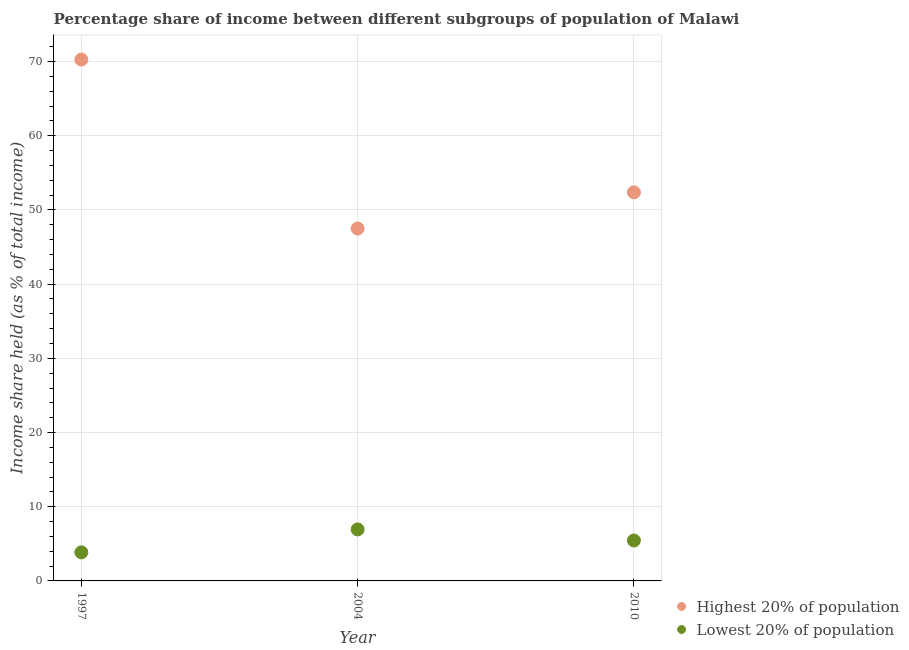How many different coloured dotlines are there?
Provide a succinct answer. 2. What is the income share held by lowest 20% of the population in 1997?
Offer a very short reply. 3.85. Across all years, what is the maximum income share held by highest 20% of the population?
Offer a terse response. 70.27. Across all years, what is the minimum income share held by lowest 20% of the population?
Your answer should be very brief. 3.85. In which year was the income share held by lowest 20% of the population minimum?
Your answer should be compact. 1997. What is the total income share held by highest 20% of the population in the graph?
Provide a short and direct response. 170.13. What is the difference between the income share held by lowest 20% of the population in 1997 and that in 2004?
Give a very brief answer. -3.09. What is the difference between the income share held by highest 20% of the population in 2010 and the income share held by lowest 20% of the population in 2004?
Your answer should be compact. 45.43. What is the average income share held by highest 20% of the population per year?
Provide a short and direct response. 56.71. In the year 1997, what is the difference between the income share held by highest 20% of the population and income share held by lowest 20% of the population?
Offer a very short reply. 66.42. What is the ratio of the income share held by highest 20% of the population in 1997 to that in 2010?
Provide a succinct answer. 1.34. Is the income share held by lowest 20% of the population in 1997 less than that in 2004?
Ensure brevity in your answer.  Yes. What is the difference between the highest and the second highest income share held by lowest 20% of the population?
Offer a very short reply. 1.49. What is the difference between the highest and the lowest income share held by lowest 20% of the population?
Your answer should be very brief. 3.09. In how many years, is the income share held by lowest 20% of the population greater than the average income share held by lowest 20% of the population taken over all years?
Keep it short and to the point. 2. Is the income share held by highest 20% of the population strictly greater than the income share held by lowest 20% of the population over the years?
Keep it short and to the point. Yes. Is the income share held by lowest 20% of the population strictly less than the income share held by highest 20% of the population over the years?
Your response must be concise. Yes. How many dotlines are there?
Your answer should be very brief. 2. How many years are there in the graph?
Make the answer very short. 3. What is the difference between two consecutive major ticks on the Y-axis?
Make the answer very short. 10. How are the legend labels stacked?
Provide a short and direct response. Vertical. What is the title of the graph?
Provide a succinct answer. Percentage share of income between different subgroups of population of Malawi. Does "Foreign Liabilities" appear as one of the legend labels in the graph?
Your answer should be very brief. No. What is the label or title of the X-axis?
Your answer should be compact. Year. What is the label or title of the Y-axis?
Give a very brief answer. Income share held (as % of total income). What is the Income share held (as % of total income) of Highest 20% of population in 1997?
Provide a short and direct response. 70.27. What is the Income share held (as % of total income) in Lowest 20% of population in 1997?
Keep it short and to the point. 3.85. What is the Income share held (as % of total income) in Highest 20% of population in 2004?
Provide a succinct answer. 47.49. What is the Income share held (as % of total income) in Lowest 20% of population in 2004?
Your answer should be compact. 6.94. What is the Income share held (as % of total income) of Highest 20% of population in 2010?
Offer a terse response. 52.37. What is the Income share held (as % of total income) of Lowest 20% of population in 2010?
Provide a short and direct response. 5.45. Across all years, what is the maximum Income share held (as % of total income) of Highest 20% of population?
Ensure brevity in your answer.  70.27. Across all years, what is the maximum Income share held (as % of total income) of Lowest 20% of population?
Your answer should be compact. 6.94. Across all years, what is the minimum Income share held (as % of total income) in Highest 20% of population?
Offer a terse response. 47.49. Across all years, what is the minimum Income share held (as % of total income) of Lowest 20% of population?
Your answer should be very brief. 3.85. What is the total Income share held (as % of total income) in Highest 20% of population in the graph?
Give a very brief answer. 170.13. What is the total Income share held (as % of total income) in Lowest 20% of population in the graph?
Provide a succinct answer. 16.24. What is the difference between the Income share held (as % of total income) in Highest 20% of population in 1997 and that in 2004?
Make the answer very short. 22.78. What is the difference between the Income share held (as % of total income) in Lowest 20% of population in 1997 and that in 2004?
Your answer should be very brief. -3.09. What is the difference between the Income share held (as % of total income) in Highest 20% of population in 2004 and that in 2010?
Keep it short and to the point. -4.88. What is the difference between the Income share held (as % of total income) of Lowest 20% of population in 2004 and that in 2010?
Provide a succinct answer. 1.49. What is the difference between the Income share held (as % of total income) in Highest 20% of population in 1997 and the Income share held (as % of total income) in Lowest 20% of population in 2004?
Your answer should be compact. 63.33. What is the difference between the Income share held (as % of total income) in Highest 20% of population in 1997 and the Income share held (as % of total income) in Lowest 20% of population in 2010?
Keep it short and to the point. 64.82. What is the difference between the Income share held (as % of total income) of Highest 20% of population in 2004 and the Income share held (as % of total income) of Lowest 20% of population in 2010?
Keep it short and to the point. 42.04. What is the average Income share held (as % of total income) of Highest 20% of population per year?
Provide a succinct answer. 56.71. What is the average Income share held (as % of total income) in Lowest 20% of population per year?
Ensure brevity in your answer.  5.41. In the year 1997, what is the difference between the Income share held (as % of total income) of Highest 20% of population and Income share held (as % of total income) of Lowest 20% of population?
Offer a very short reply. 66.42. In the year 2004, what is the difference between the Income share held (as % of total income) of Highest 20% of population and Income share held (as % of total income) of Lowest 20% of population?
Keep it short and to the point. 40.55. In the year 2010, what is the difference between the Income share held (as % of total income) in Highest 20% of population and Income share held (as % of total income) in Lowest 20% of population?
Your response must be concise. 46.92. What is the ratio of the Income share held (as % of total income) in Highest 20% of population in 1997 to that in 2004?
Provide a succinct answer. 1.48. What is the ratio of the Income share held (as % of total income) of Lowest 20% of population in 1997 to that in 2004?
Make the answer very short. 0.55. What is the ratio of the Income share held (as % of total income) in Highest 20% of population in 1997 to that in 2010?
Your answer should be compact. 1.34. What is the ratio of the Income share held (as % of total income) of Lowest 20% of population in 1997 to that in 2010?
Provide a succinct answer. 0.71. What is the ratio of the Income share held (as % of total income) in Highest 20% of population in 2004 to that in 2010?
Your answer should be compact. 0.91. What is the ratio of the Income share held (as % of total income) of Lowest 20% of population in 2004 to that in 2010?
Make the answer very short. 1.27. What is the difference between the highest and the second highest Income share held (as % of total income) in Highest 20% of population?
Your response must be concise. 17.9. What is the difference between the highest and the second highest Income share held (as % of total income) in Lowest 20% of population?
Your answer should be compact. 1.49. What is the difference between the highest and the lowest Income share held (as % of total income) in Highest 20% of population?
Your answer should be compact. 22.78. What is the difference between the highest and the lowest Income share held (as % of total income) in Lowest 20% of population?
Make the answer very short. 3.09. 